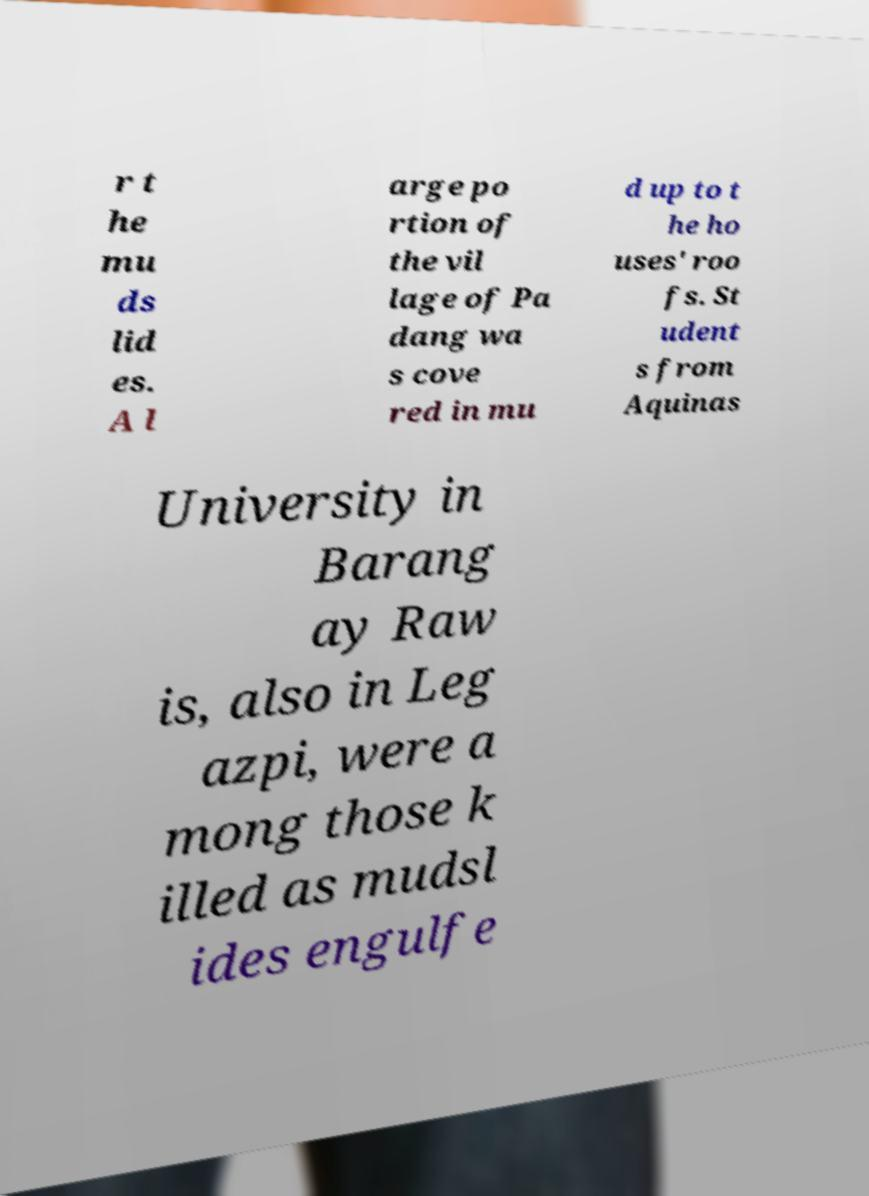I need the written content from this picture converted into text. Can you do that? r t he mu ds lid es. A l arge po rtion of the vil lage of Pa dang wa s cove red in mu d up to t he ho uses' roo fs. St udent s from Aquinas University in Barang ay Raw is, also in Leg azpi, were a mong those k illed as mudsl ides engulfe 